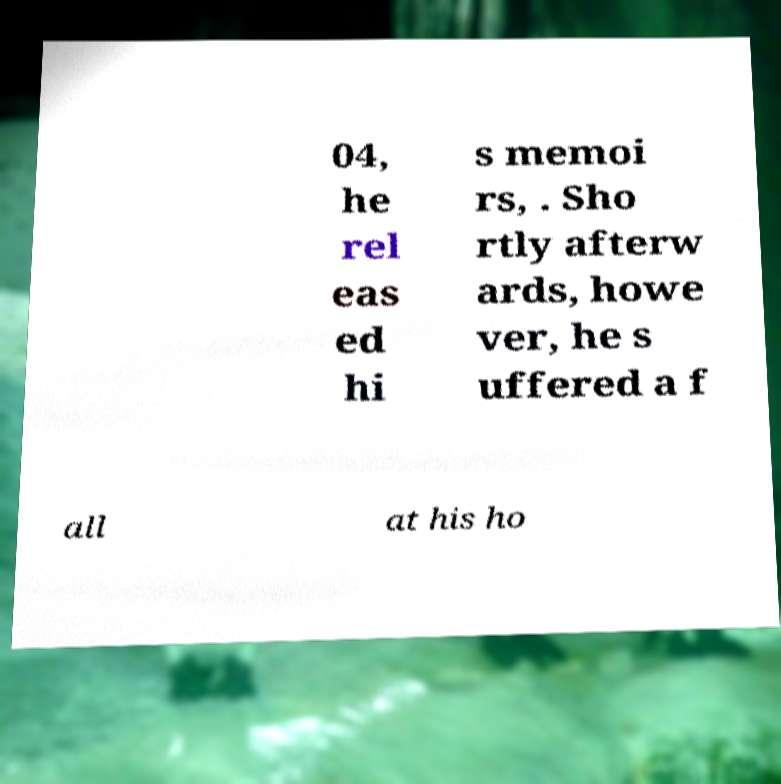I need the written content from this picture converted into text. Can you do that? 04, he rel eas ed hi s memoi rs, . Sho rtly afterw ards, howe ver, he s uffered a f all at his ho 